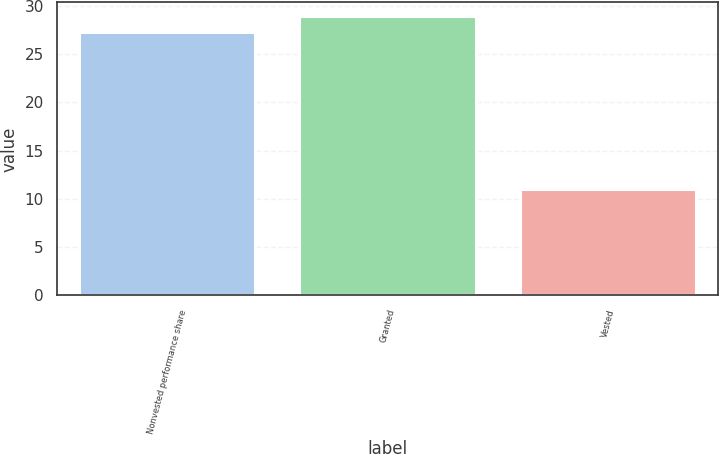Convert chart to OTSL. <chart><loc_0><loc_0><loc_500><loc_500><bar_chart><fcel>Nonvested performance share<fcel>Granted<fcel>Vested<nl><fcel>27.28<fcel>28.92<fcel>11.07<nl></chart> 